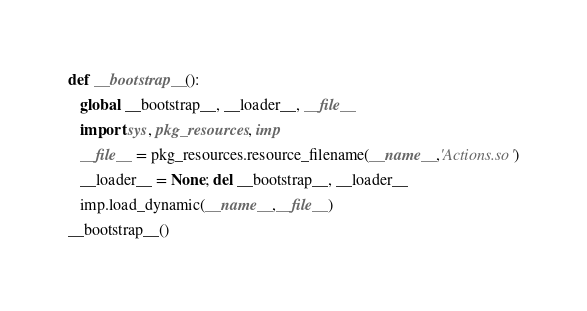<code> <loc_0><loc_0><loc_500><loc_500><_Python_>def __bootstrap__():
   global __bootstrap__, __loader__, __file__
   import sys, pkg_resources, imp
   __file__ = pkg_resources.resource_filename(__name__,'Actions.so')
   __loader__ = None; del __bootstrap__, __loader__
   imp.load_dynamic(__name__,__file__)
__bootstrap__()
</code> 